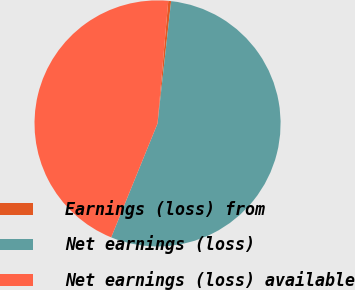Convert chart to OTSL. <chart><loc_0><loc_0><loc_500><loc_500><pie_chart><fcel>Earnings (loss) from<fcel>Net earnings (loss)<fcel>Net earnings (loss) available<nl><fcel>0.37%<fcel>54.39%<fcel>45.24%<nl></chart> 